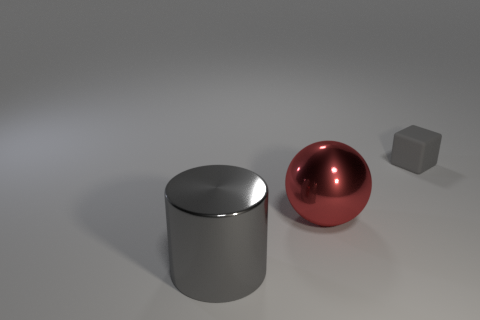Subtract all green blocks. Subtract all blue spheres. How many blocks are left? 1 Subtract all yellow balls. How many red blocks are left? 0 Add 2 small grays. How many big reds exist? 0 Subtract all big purple matte cylinders. Subtract all tiny gray objects. How many objects are left? 2 Add 3 red objects. How many red objects are left? 4 Add 3 gray metallic spheres. How many gray metallic spheres exist? 3 Add 1 gray metal spheres. How many objects exist? 4 Subtract 0 yellow balls. How many objects are left? 3 Subtract all blocks. How many objects are left? 2 Subtract 1 balls. How many balls are left? 0 